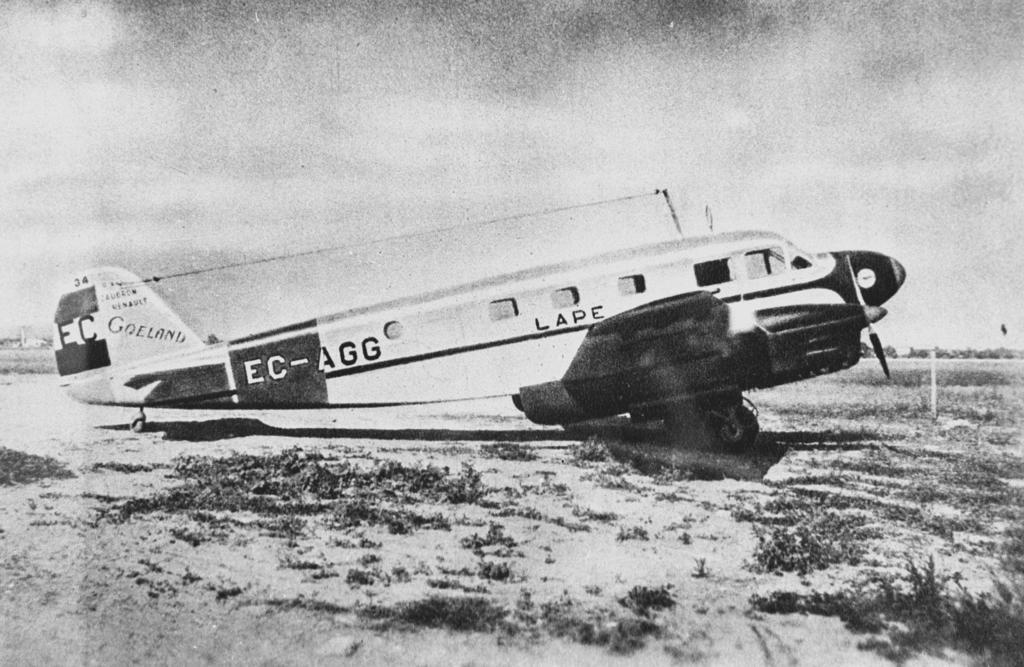<image>
Relay a brief, clear account of the picture shown. a Lape plane sitting on a field shown in black and white 